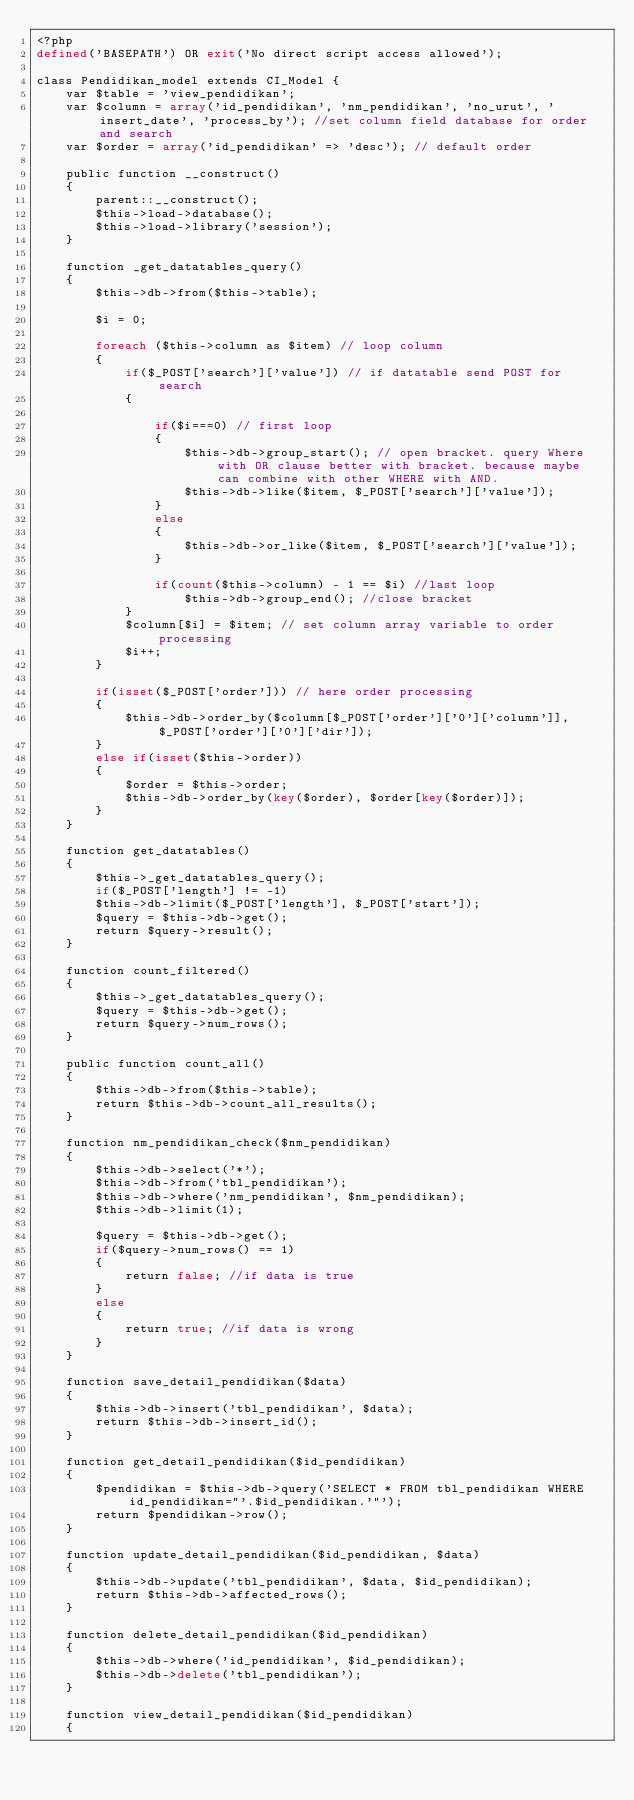<code> <loc_0><loc_0><loc_500><loc_500><_PHP_><?php
defined('BASEPATH') OR exit('No direct script access allowed');

class Pendidikan_model extends CI_Model {
	var $table = 'view_pendidikan';
	var $column = array('id_pendidikan', 'nm_pendidikan', 'no_urut', 'insert_date', 'process_by'); //set column field database for order and search
	var $order = array('id_pendidikan' => 'desc'); // default order 
	
	public function __construct()
	{
		parent::__construct();
		$this->load->database();
		$this->load->library('session');
	}
	
	function _get_datatables_query()
	{
		$this->db->from($this->table);

		$i = 0;
	
		foreach ($this->column as $item) // loop column 
		{
			if($_POST['search']['value']) // if datatable send POST for search
			{
				
				if($i===0) // first loop
				{
					$this->db->group_start(); // open bracket. query Where with OR clause better with bracket. because maybe can combine with other WHERE with AND. 
					$this->db->like($item, $_POST['search']['value']);
				}
				else
				{
					$this->db->or_like($item, $_POST['search']['value']);
				}

				if(count($this->column) - 1 == $i) //last loop
					$this->db->group_end(); //close bracket
			}
			$column[$i] = $item; // set column array variable to order processing
			$i++;
		}
		
		if(isset($_POST['order'])) // here order processing
		{
			$this->db->order_by($column[$_POST['order']['0']['column']], $_POST['order']['0']['dir']);
		} 
		else if(isset($this->order))
		{
			$order = $this->order;
			$this->db->order_by(key($order), $order[key($order)]);
		}
	}
	
	function get_datatables()
	{
		$this->_get_datatables_query();
		if($_POST['length'] != -1)
		$this->db->limit($_POST['length'], $_POST['start']);
		$query = $this->db->get();
		return $query->result();
	}

	function count_filtered()
	{
		$this->_get_datatables_query();
		$query = $this->db->get();
		return $query->num_rows();
	}

	public function count_all()
	{
		$this->db->from($this->table);
		return $this->db->count_all_results();
	}
	
	function nm_pendidikan_check($nm_pendidikan)
	{
		$this->db->select('*');
        $this->db->from('tbl_pendidikan');
        $this->db->where('nm_pendidikan', $nm_pendidikan);
        $this->db->limit(1);
		
		$query = $this->db->get();
        if($query->num_rows() == 1)
		{
            return false; //if data is true
        }
		else
		{
            return true; //if data is wrong
        }
	}
	
	function save_detail_pendidikan($data)
	{
		$this->db->insert('tbl_pendidikan', $data);
		return $this->db->insert_id();				   
	}
	
	function get_detail_pendidikan($id_pendidikan)
	{
		$pendidikan = $this->db->query('SELECT * FROM tbl_pendidikan WHERE id_pendidikan="'.$id_pendidikan.'"');
		return $pendidikan->row();						   
	}
	
	function update_detail_pendidikan($id_pendidikan, $data)
	{
		$this->db->update('tbl_pendidikan', $data, $id_pendidikan);
		return $this->db->affected_rows();			   
	}
	
	function delete_detail_pendidikan($id_pendidikan)
	{
		$this->db->where('id_pendidikan', $id_pendidikan);
		$this->db->delete('tbl_pendidikan');
	}
	
	function view_detail_pendidikan($id_pendidikan)
	{</code> 